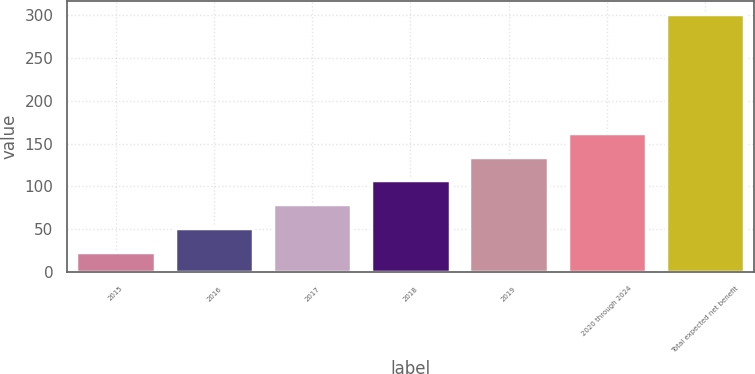<chart> <loc_0><loc_0><loc_500><loc_500><bar_chart><fcel>2015<fcel>2016<fcel>2017<fcel>2018<fcel>2019<fcel>2020 through 2024<fcel>Total expected net benefit<nl><fcel>24<fcel>51.7<fcel>79.4<fcel>107.1<fcel>134.8<fcel>162.5<fcel>301<nl></chart> 